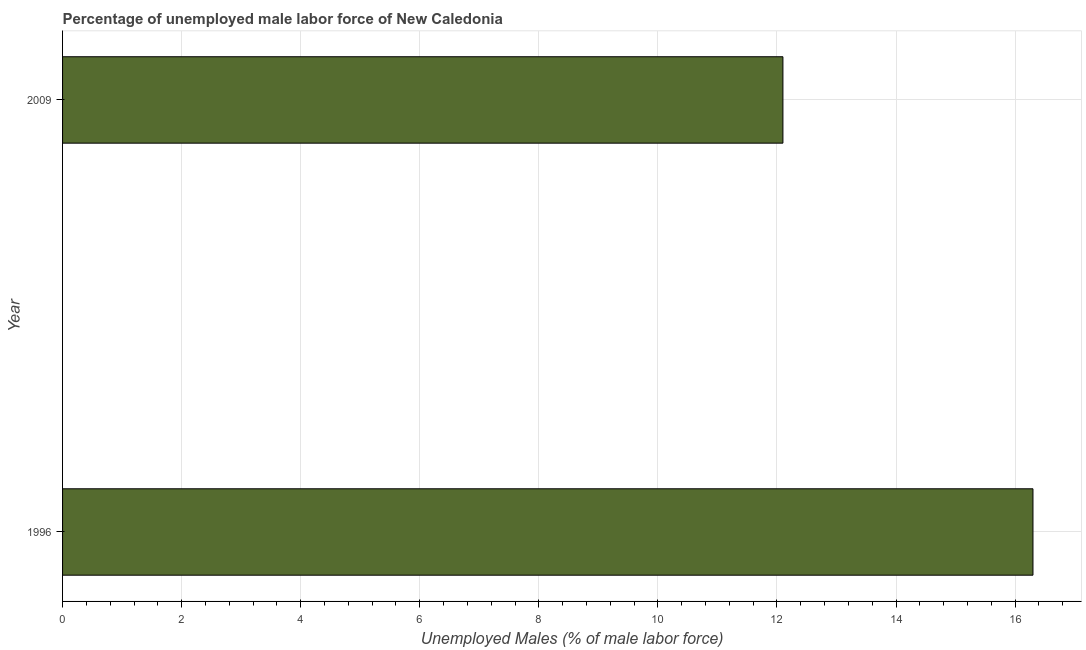Does the graph contain grids?
Ensure brevity in your answer.  Yes. What is the title of the graph?
Offer a very short reply. Percentage of unemployed male labor force of New Caledonia. What is the label or title of the X-axis?
Your answer should be compact. Unemployed Males (% of male labor force). What is the label or title of the Y-axis?
Make the answer very short. Year. What is the total unemployed male labour force in 2009?
Ensure brevity in your answer.  12.1. Across all years, what is the maximum total unemployed male labour force?
Ensure brevity in your answer.  16.3. Across all years, what is the minimum total unemployed male labour force?
Your response must be concise. 12.1. In which year was the total unemployed male labour force maximum?
Your response must be concise. 1996. In which year was the total unemployed male labour force minimum?
Keep it short and to the point. 2009. What is the sum of the total unemployed male labour force?
Offer a terse response. 28.4. What is the difference between the total unemployed male labour force in 1996 and 2009?
Your answer should be compact. 4.2. What is the average total unemployed male labour force per year?
Offer a terse response. 14.2. What is the median total unemployed male labour force?
Offer a terse response. 14.2. What is the ratio of the total unemployed male labour force in 1996 to that in 2009?
Provide a succinct answer. 1.35. Is the total unemployed male labour force in 1996 less than that in 2009?
Your answer should be very brief. No. In how many years, is the total unemployed male labour force greater than the average total unemployed male labour force taken over all years?
Offer a very short reply. 1. How many bars are there?
Provide a short and direct response. 2. How many years are there in the graph?
Give a very brief answer. 2. What is the Unemployed Males (% of male labor force) in 1996?
Give a very brief answer. 16.3. What is the Unemployed Males (% of male labor force) of 2009?
Offer a very short reply. 12.1. What is the difference between the Unemployed Males (% of male labor force) in 1996 and 2009?
Make the answer very short. 4.2. What is the ratio of the Unemployed Males (% of male labor force) in 1996 to that in 2009?
Offer a terse response. 1.35. 